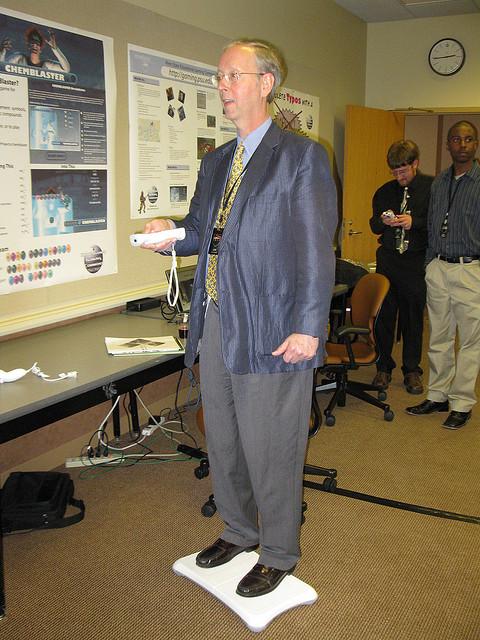What time is it?
Quick response, please. 2:45. Which hand is he holding the controller with?
Write a very short answer. Right. What is he doing?
Be succinct. Playing wii. 